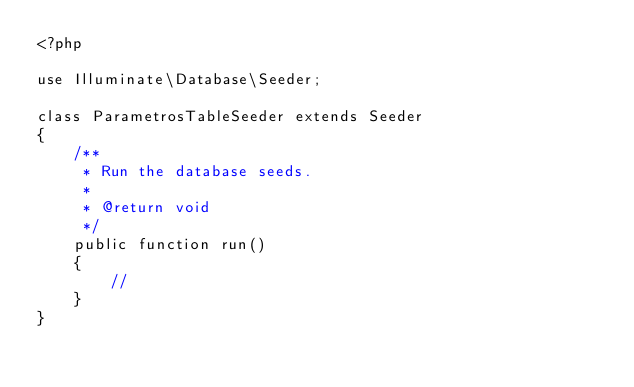<code> <loc_0><loc_0><loc_500><loc_500><_PHP_><?php

use Illuminate\Database\Seeder;

class ParametrosTableSeeder extends Seeder
{
    /**
     * Run the database seeds.
     *
     * @return void
     */
    public function run()
    {
        //
    }
}
</code> 